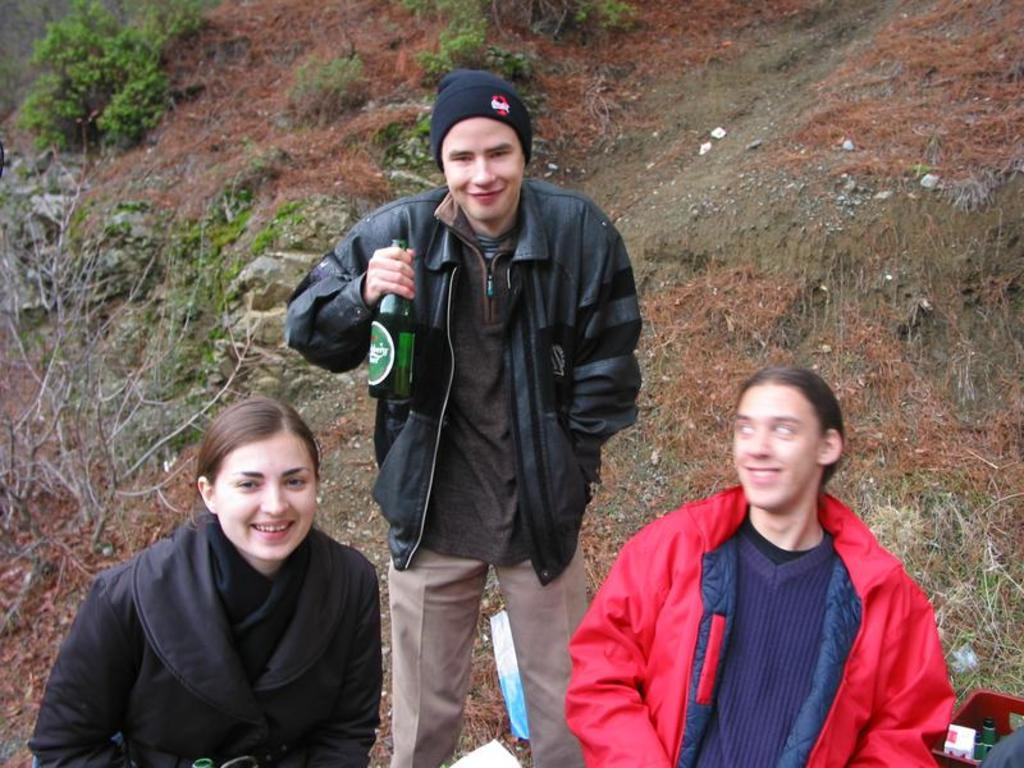How many people are in the image? There are three persons in the image. What is the facial expression of the people in the image? The persons are smiling. What can be seen inside the plastic container? There are items in a plastic container. What is a person holding in the image? A person is holding a bottle. What type of vegetation is visible in the background of the image? There are plants in the background of the image. What type of chain is being used to restrain the goat in the image? There is no goat or chain present in the image. What is the front of the image showing? The provided facts do not specify any particular front or orientation of the image. 